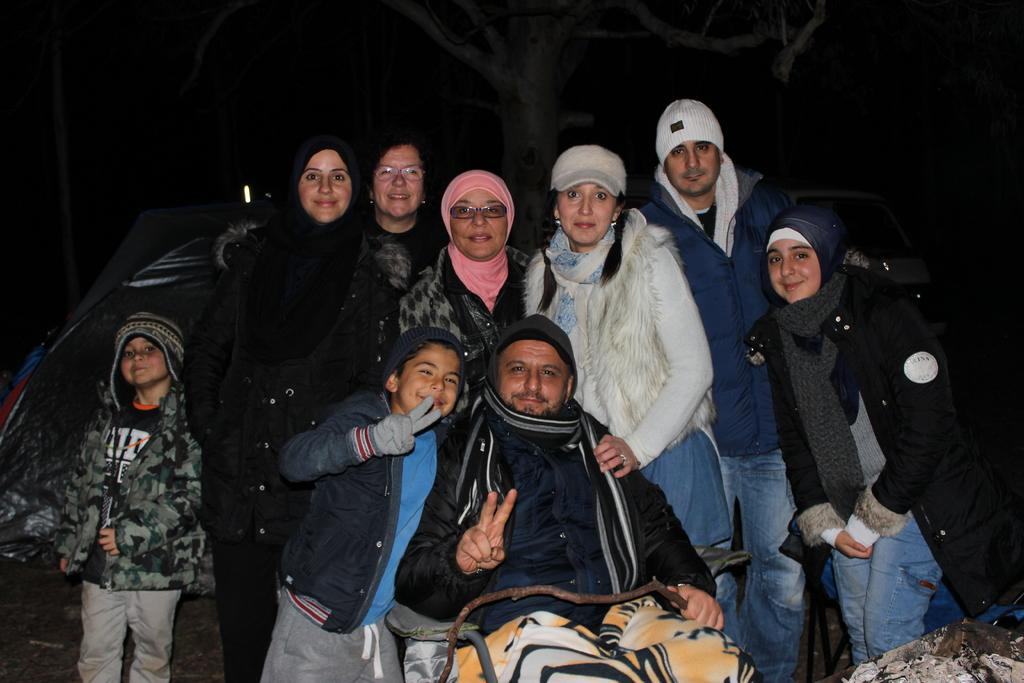How many people are in the group in the image? There is a group of persons in the image, including two children. What is the position of one person in the group? One person is sitting on a chair. What is the general mood of the group in the image? The group is standing and smiling, indicating a positive mood. Where is the scene taking place? The scene is on a road. What is the color of the background in the image? The background is dark in color. What type of box is being used by the manager in the image? There is no manager or box present in the image. What is the addition to the group that is not visible in the image? There is no additional person or object mentioned in the facts provided, so it is impossible to determine what might be added to the group. 